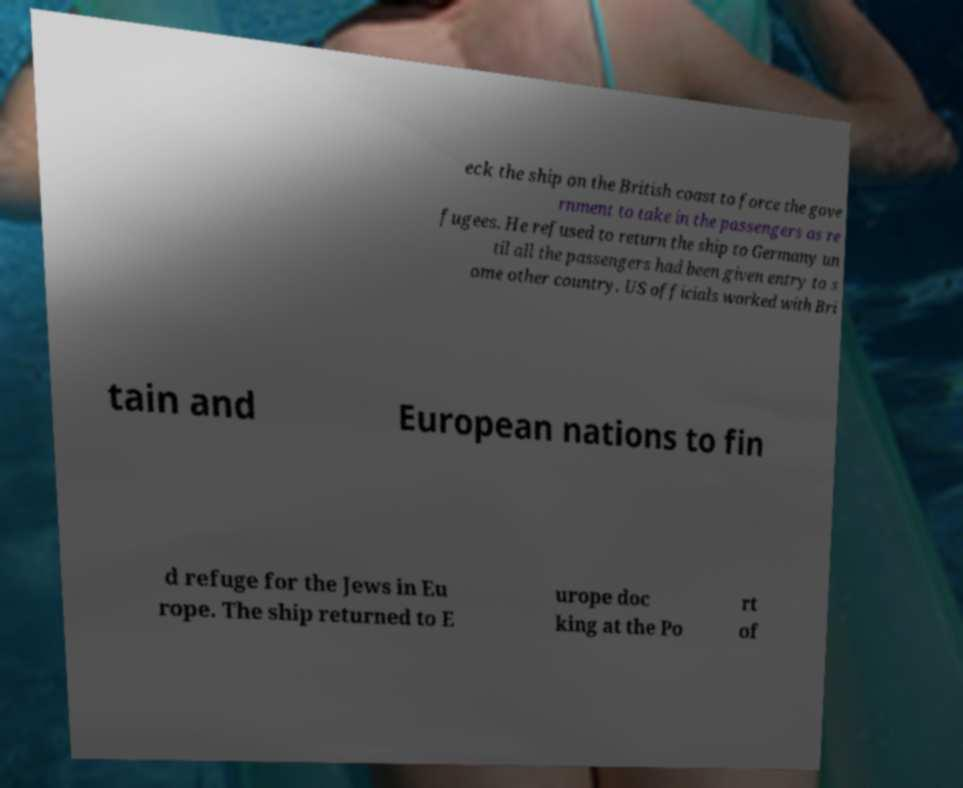Could you assist in decoding the text presented in this image and type it out clearly? eck the ship on the British coast to force the gove rnment to take in the passengers as re fugees. He refused to return the ship to Germany un til all the passengers had been given entry to s ome other country. US officials worked with Bri tain and European nations to fin d refuge for the Jews in Eu rope. The ship returned to E urope doc king at the Po rt of 